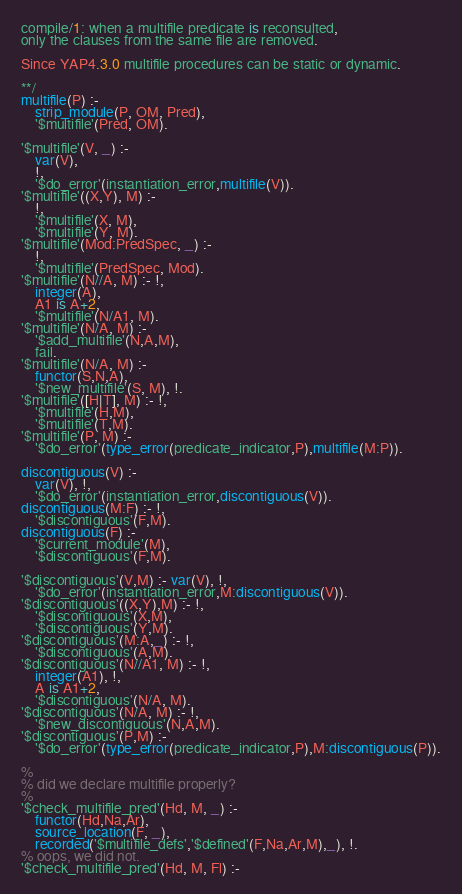<code> <loc_0><loc_0><loc_500><loc_500><_Prolog_>compile/1: when a multifile predicate is reconsulted,
only the clauses from the same file are removed.

Since YAP4.3.0 multifile procedures can be static or dynamic.

**/
multifile(P) :-
    strip_module(P, OM, Pred),
	'$multifile'(Pred, OM).

'$multifile'(V, _) :-
    var(V),
    !,
	'$do_error'(instantiation_error,multifile(V)).
'$multifile'((X,Y), M) :-
    !,
    '$multifile'(X, M),
    '$multifile'(Y, M).
'$multifile'(Mod:PredSpec, _) :-
    !,
	'$multifile'(PredSpec, Mod).
'$multifile'(N//A, M) :- !,
	integer(A),
	A1 is A+2,
	'$multifile'(N/A1, M).
'$multifile'(N/A, M) :-
	'$add_multifile'(N,A,M),
	fail.
'$multifile'(N/A, M) :-
    functor(S,N,A),
	'$new_multifile'(S, M), !.
'$multifile'([H|T], M) :- !,
	'$multifile'(H,M),
	'$multifile'(T,M).
'$multifile'(P, M) :-
	'$do_error'(type_error(predicate_indicator,P),multifile(M:P)).

discontiguous(V) :-
	var(V), !,
	'$do_error'(instantiation_error,discontiguous(V)).
discontiguous(M:F) :- !,
	'$discontiguous'(F,M).
discontiguous(F) :-
	'$current_module'(M),
	'$discontiguous'(F,M).

'$discontiguous'(V,M) :- var(V), !,
	'$do_error'(instantiation_error,M:discontiguous(V)).
'$discontiguous'((X,Y),M) :- !,
	'$discontiguous'(X,M),
	'$discontiguous'(Y,M).
'$discontiguous'(M:A,_) :- !,
	'$discontiguous'(A,M).
'$discontiguous'(N//A1, M) :- !,
	integer(A1), !,
	A is A1+2,
	'$discontiguous'(N/A, M).
'$discontiguous'(N/A, M) :- !,
	'$new_discontiguous'(N,A,M).
'$discontiguous'(P,M) :-
	'$do_error'(type_error(predicate_indicator,P),M:discontiguous(P)).

%
% did we declare multifile properly?
%
'$check_multifile_pred'(Hd, M, _) :-
	functor(Hd,Na,Ar),
	source_location(F, _),
	recorded('$multifile_defs','$defined'(F,Na,Ar,M),_), !.
% oops, we did not.
'$check_multifile_pred'(Hd, M, Fl) :-</code> 